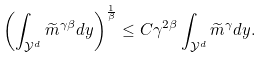Convert formula to latex. <formula><loc_0><loc_0><loc_500><loc_500>\left ( \int _ { \mathcal { Y } ^ { d } } \widetilde { m } ^ { \gamma \beta } d y \right ) ^ { \frac { 1 } { \beta } } \leq C \gamma ^ { 2 \beta } \int _ { \mathcal { Y } ^ { d } } \widetilde { m } ^ { \gamma } d y .</formula> 